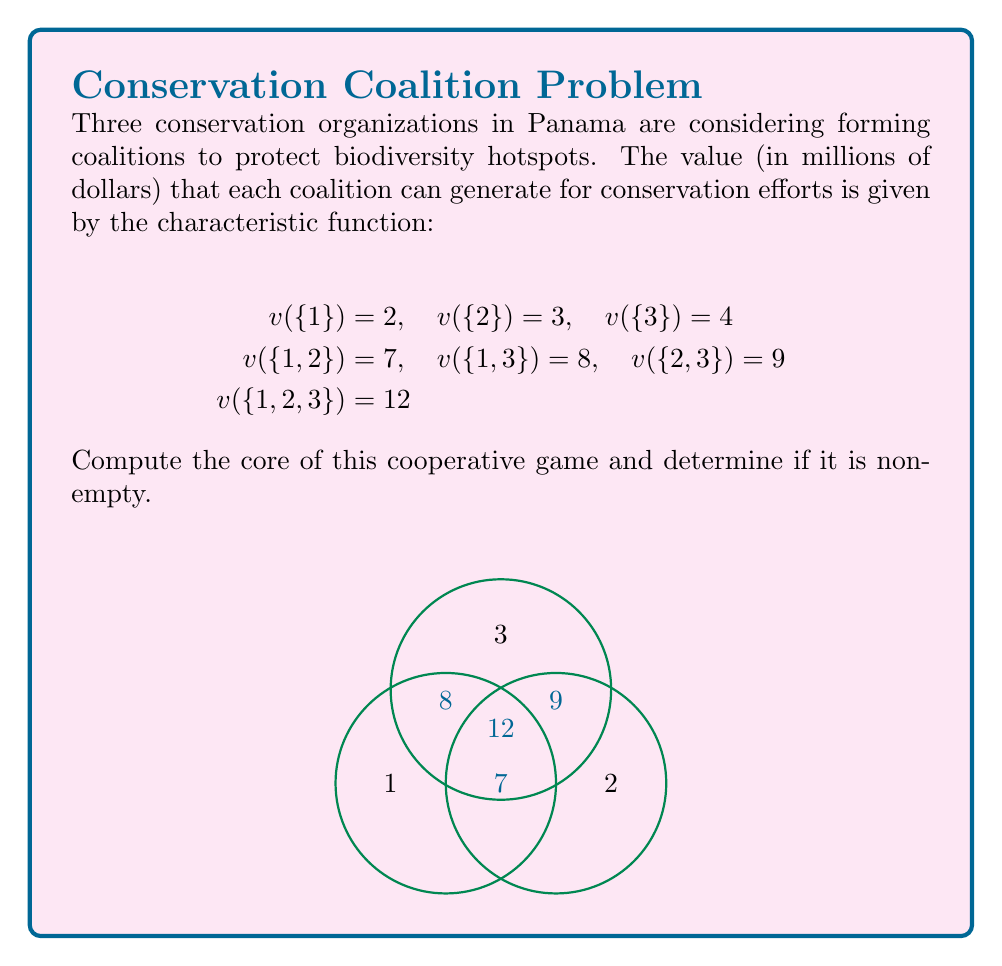Provide a solution to this math problem. To compute the core of this cooperative game, we need to find all allocations $(x_1, x_2, x_3)$ that satisfy the following conditions:

1. Efficiency: $x_1 + x_2 + x_3 = v(\{1,2,3\}) = 12$
2. Individual rationality: $x_1 \geq 2, x_2 \geq 3, x_3 \geq 4$
3. Coalition rationality: $x_1 + x_2 \geq 7, x_1 + x_3 \geq 8, x_2 + x_3 \geq 9$

Let's solve this step by step:

Step 1: From individual rationality, we know that:
$x_1 \geq 2, x_2 \geq 3, x_3 \geq 4$

Step 2: Adding these inequalities:
$x_1 + x_2 + x_3 \geq 2 + 3 + 4 = 9$

Step 3: From efficiency, we know that:
$x_1 + x_2 + x_3 = 12$

Step 4: Combining steps 2 and 3, we can conclude that the core exists and is non-empty, as the efficiency condition can be satisfied while meeting individual rationality.

Step 5: To find the core, we need to consider the coalition rationality conditions:
$x_1 + x_2 \geq 7, x_1 + x_3 \geq 8, x_2 + x_3 \geq 9$

Step 6: Combining these with the efficiency condition, we get:
$x_3 \leq 5, x_2 \leq 4, x_1 \leq 3$

Step 7: Therefore, the core is the set of all allocations $(x_1, x_2, x_3)$ that satisfy:
$$2 \leq x_1 \leq 3$$
$$3 \leq x_2 \leq 4$$
$$4 \leq x_3 \leq 5$$
$$x_1 + x_2 + x_3 = 12$$

This forms a triangle in 3D space, which is the core of the game.
Answer: Non-empty core: $\{(x_1, x_2, x_3) | 2 \leq x_1 \leq 3, 3 \leq x_2 \leq 4, 4 \leq x_3 \leq 5, x_1 + x_2 + x_3 = 12\}$ 